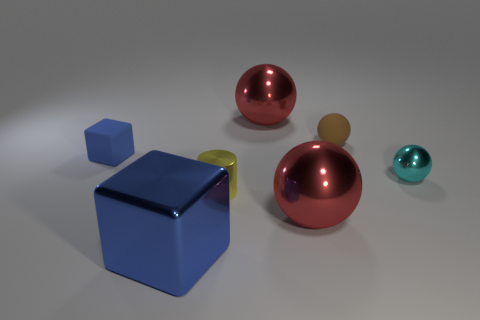What size is the metallic cube?
Offer a very short reply. Large. The yellow metallic object has what shape?
Make the answer very short. Cylinder. Are there any other things that are the same shape as the cyan thing?
Your answer should be very brief. Yes. Are there fewer tiny brown matte spheres that are behind the tiny brown ball than red metallic things?
Keep it short and to the point. Yes. Does the small shiny thing that is behind the tiny yellow metallic cylinder have the same color as the big metallic block?
Your response must be concise. No. What number of shiny things are either blue things or brown things?
Offer a terse response. 1. Is there anything else that has the same size as the brown matte object?
Offer a very short reply. Yes. What color is the tiny object that is made of the same material as the small cylinder?
Your response must be concise. Cyan. What number of balls are red metal things or tiny matte things?
Provide a succinct answer. 3. How many things are small brown objects or tiny things behind the shiny cylinder?
Give a very brief answer. 3. 